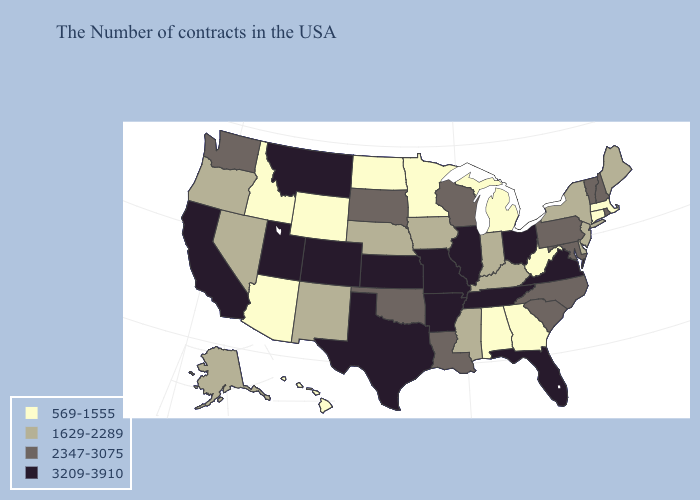Does California have the highest value in the West?
Keep it brief. Yes. What is the highest value in the West ?
Quick response, please. 3209-3910. Name the states that have a value in the range 3209-3910?
Concise answer only. Virginia, Ohio, Florida, Tennessee, Illinois, Missouri, Arkansas, Kansas, Texas, Colorado, Utah, Montana, California. What is the highest value in the Northeast ?
Quick response, please. 2347-3075. What is the value of West Virginia?
Short answer required. 569-1555. Which states have the lowest value in the USA?
Concise answer only. Massachusetts, Connecticut, West Virginia, Georgia, Michigan, Alabama, Minnesota, North Dakota, Wyoming, Arizona, Idaho, Hawaii. Which states hav the highest value in the MidWest?
Quick response, please. Ohio, Illinois, Missouri, Kansas. Which states have the lowest value in the USA?
Keep it brief. Massachusetts, Connecticut, West Virginia, Georgia, Michigan, Alabama, Minnesota, North Dakota, Wyoming, Arizona, Idaho, Hawaii. What is the highest value in the West ?
Keep it brief. 3209-3910. What is the lowest value in states that border Nebraska?
Keep it brief. 569-1555. Name the states that have a value in the range 1629-2289?
Write a very short answer. Maine, New York, New Jersey, Delaware, Kentucky, Indiana, Mississippi, Iowa, Nebraska, New Mexico, Nevada, Oregon, Alaska. What is the value of Washington?
Give a very brief answer. 2347-3075. Which states have the lowest value in the South?
Give a very brief answer. West Virginia, Georgia, Alabama. Which states have the lowest value in the USA?
Concise answer only. Massachusetts, Connecticut, West Virginia, Georgia, Michigan, Alabama, Minnesota, North Dakota, Wyoming, Arizona, Idaho, Hawaii. What is the highest value in states that border Oklahoma?
Answer briefly. 3209-3910. 